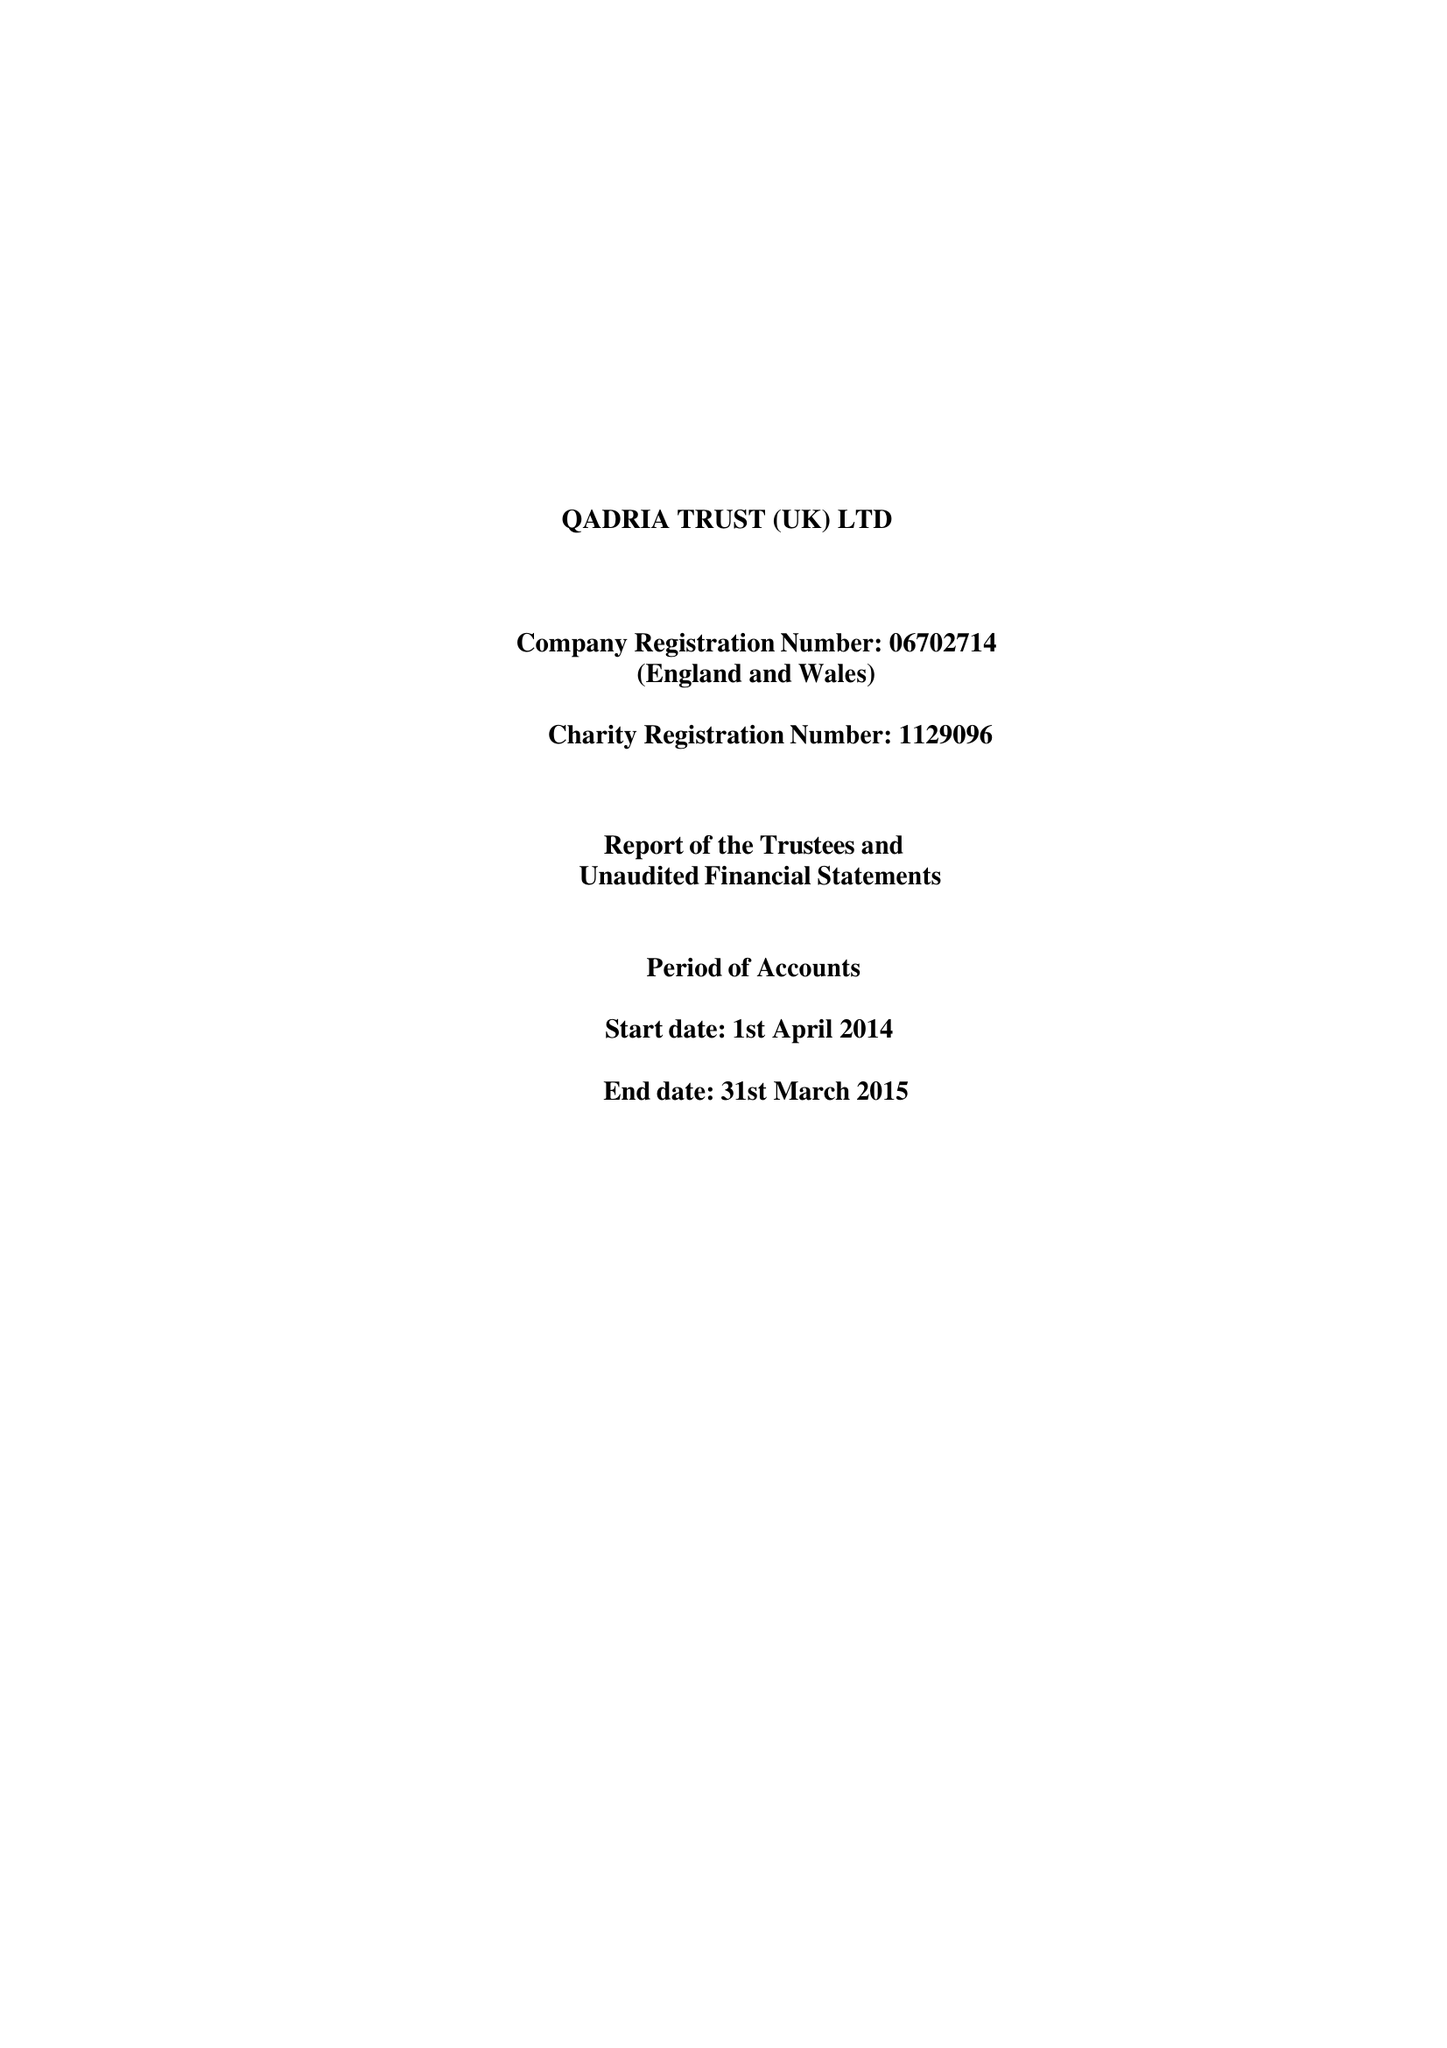What is the value for the spending_annually_in_british_pounds?
Answer the question using a single word or phrase. 87937.00 